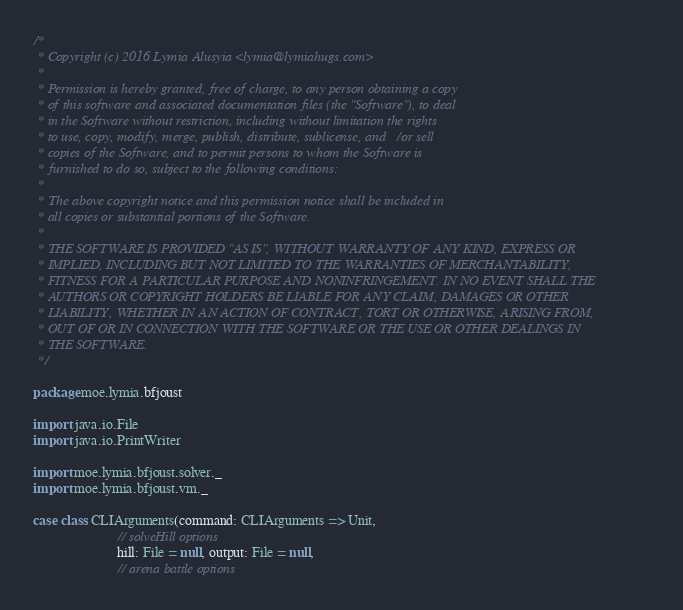<code> <loc_0><loc_0><loc_500><loc_500><_Scala_>/*
 * Copyright (c) 2016 Lymia Alusyia <lymia@lymiahugs.com>
 *
 * Permission is hereby granted, free of charge, to any person obtaining a copy
 * of this software and associated documentation files (the "Software"), to deal
 * in the Software without restriction, including without limitation the rights
 * to use, copy, modify, merge, publish, distribute, sublicense, and/or sell
 * copies of the Software, and to permit persons to whom the Software is
 * furnished to do so, subject to the following conditions:
 *
 * The above copyright notice and this permission notice shall be included in
 * all copies or substantial portions of the Software.
 *
 * THE SOFTWARE IS PROVIDED "AS IS", WITHOUT WARRANTY OF ANY KIND, EXPRESS OR
 * IMPLIED, INCLUDING BUT NOT LIMITED TO THE WARRANTIES OF MERCHANTABILITY,
 * FITNESS FOR A PARTICULAR PURPOSE AND NONINFRINGEMENT. IN NO EVENT SHALL THE
 * AUTHORS OR COPYRIGHT HOLDERS BE LIABLE FOR ANY CLAIM, DAMAGES OR OTHER
 * LIABILITY, WHETHER IN AN ACTION OF CONTRACT, TORT OR OTHERWISE, ARISING FROM,
 * OUT OF OR IN CONNECTION WITH THE SOFTWARE OR THE USE OR OTHER DEALINGS IN
 * THE SOFTWARE.
 */

package moe.lymia.bfjoust

import java.io.File
import java.io.PrintWriter

import moe.lymia.bfjoust.solver._
import moe.lymia.bfjoust.vm._

case class CLIArguments(command: CLIArguments => Unit,
                        // solveHill options
                        hill: File = null, output: File = null,
                        // arena battle options</code> 